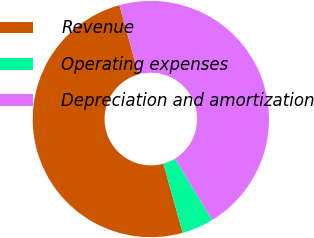Convert chart. <chart><loc_0><loc_0><loc_500><loc_500><pie_chart><fcel>Revenue<fcel>Operating expenses<fcel>Depreciation and amortization<nl><fcel>50.06%<fcel>4.34%<fcel>45.6%<nl></chart> 